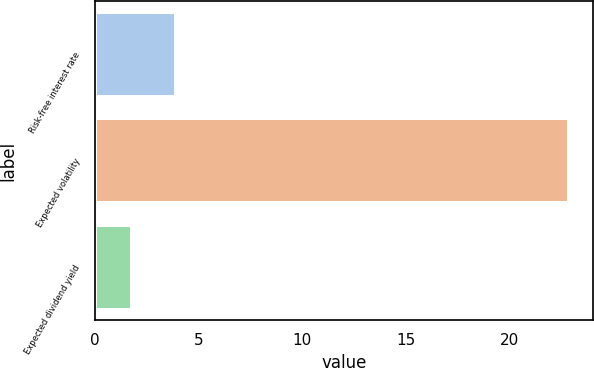Convert chart. <chart><loc_0><loc_0><loc_500><loc_500><bar_chart><fcel>Risk-free interest rate<fcel>Expected volatility<fcel>Expected dividend yield<nl><fcel>3.91<fcel>22.9<fcel>1.8<nl></chart> 